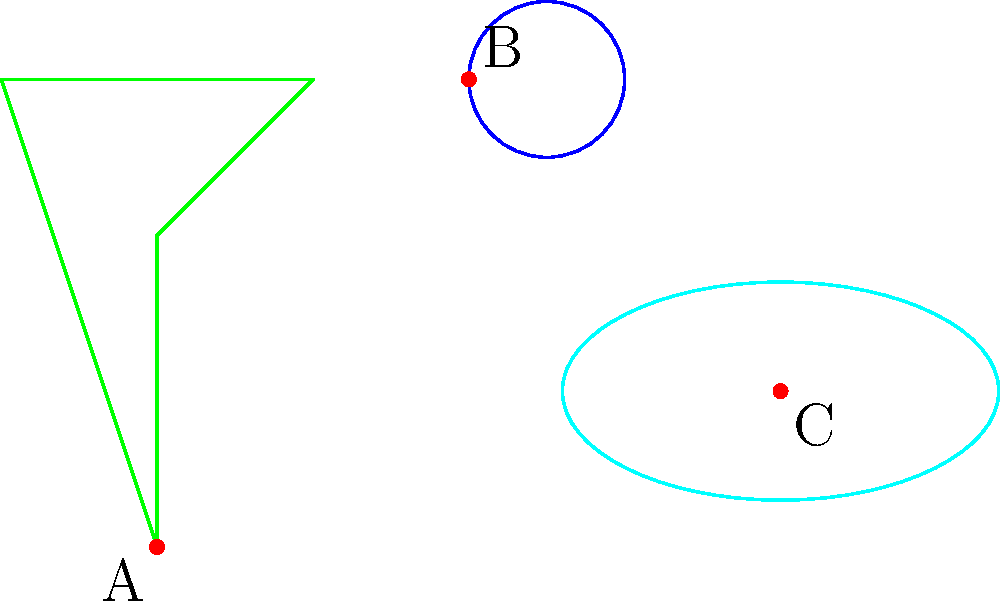In Kuindzhi's "After the Rain," we can identify simplified geometric shapes representing natural elements. Using these shapes as inspiration, create a new abstract composition by translating the tree shape to point A(1,1), the cloud shape to point B(3,4), and the puddle shape to point C(5,2). What is the total displacement vector from the tree's new position to the puddle's new position? To find the total displacement vector from the tree's new position to the puddle's new position, we need to follow these steps:

1. Identify the coordinates of the tree's new position: A(1,1)
2. Identify the coordinates of the puddle's new position: C(5,2)
3. Calculate the displacement vector by subtracting the tree's coordinates from the puddle's coordinates:

   $\vec{AC} = C - A = (5,2) - (1,1)$

4. Simplify the vector:

   $\vec{AC} = (5-1, 2-1) = (4,1)$

Therefore, the total displacement vector from the tree's new position to the puddle's new position is (4,1).
Answer: (4,1) 